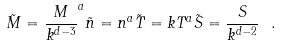<formula> <loc_0><loc_0><loc_500><loc_500>\tilde { M } = \frac { M } { k ^ { d - 3 } } ^ { a } \tilde { n } = n ^ { a } \tilde { T } = k T ^ { a } \tilde { S } = \frac { S } { k ^ { d - 2 } } \ .</formula> 